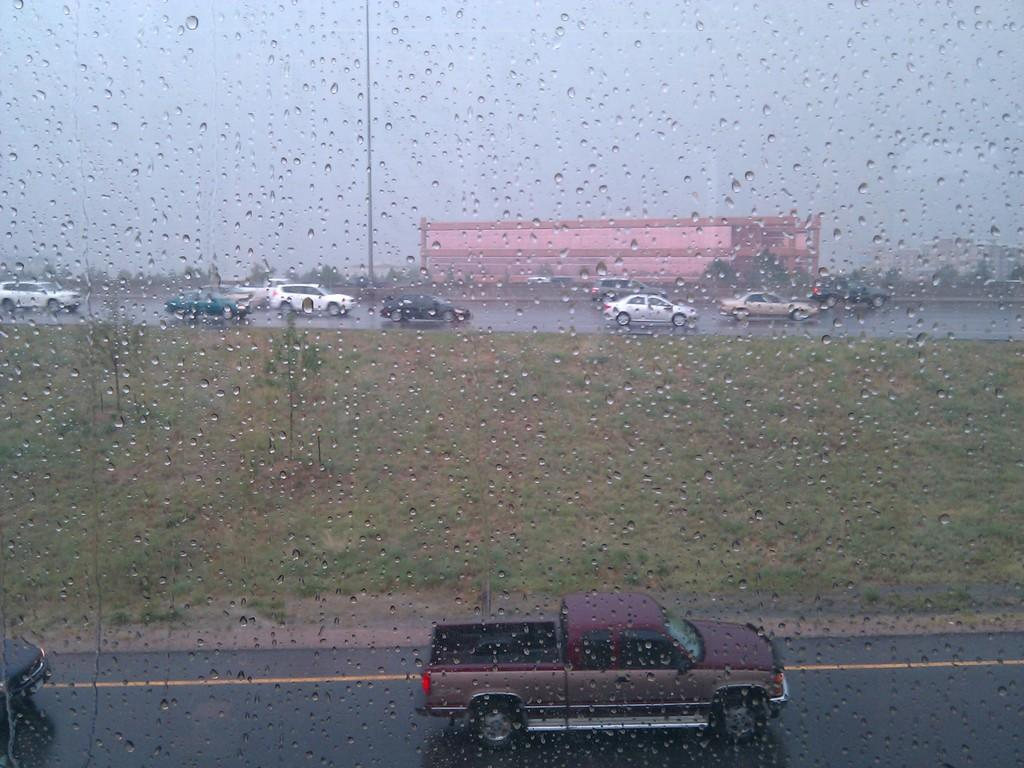What is on the glass in the image? There are water drops on the glass in the image. What can be seen behind the glass? There are cars on the road behind the glass. What type of natural elements are visible in the image? There are trees visible in the image. What type of man-made structures are visible in the image? There are buildings in the image. What type of beast is observing the dress in the image? There is no beast or dress present in the image. 